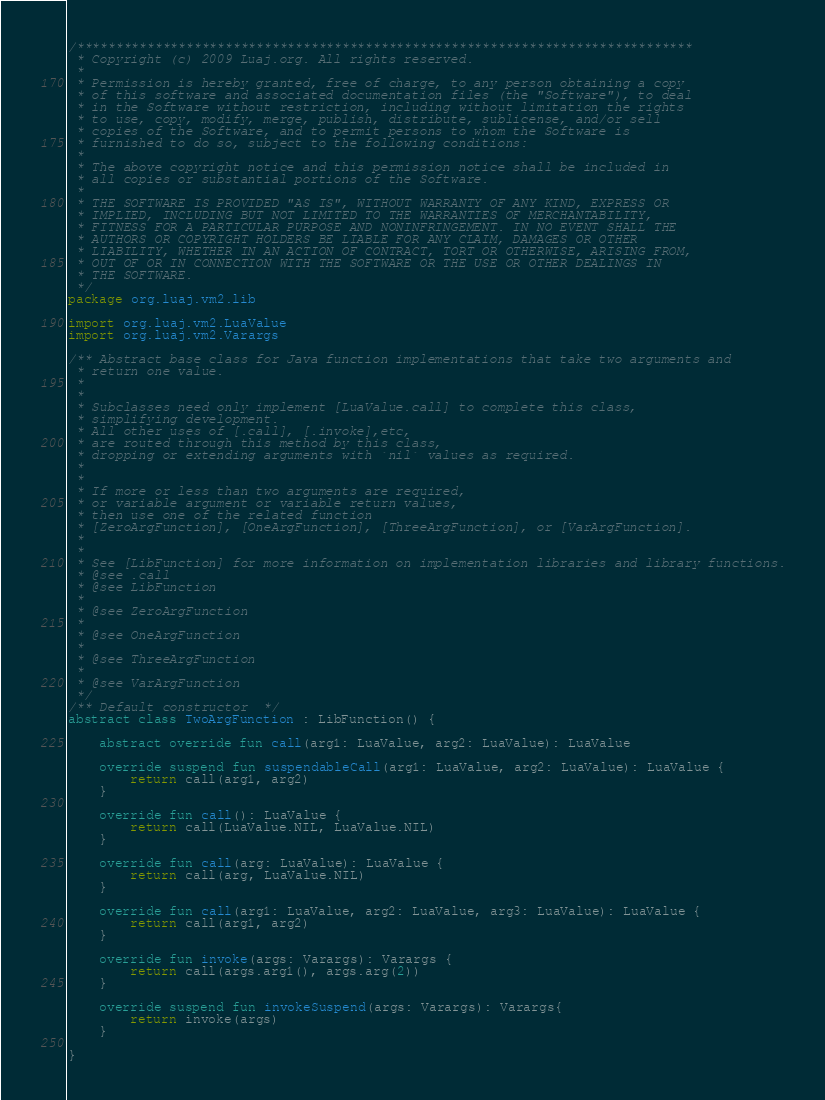Convert code to text. <code><loc_0><loc_0><loc_500><loc_500><_Kotlin_>/*******************************************************************************
 * Copyright (c) 2009 Luaj.org. All rights reserved.
 *
 * Permission is hereby granted, free of charge, to any person obtaining a copy
 * of this software and associated documentation files (the "Software"), to deal
 * in the Software without restriction, including without limitation the rights
 * to use, copy, modify, merge, publish, distribute, sublicense, and/or sell
 * copies of the Software, and to permit persons to whom the Software is
 * furnished to do so, subject to the following conditions:
 *
 * The above copyright notice and this permission notice shall be included in
 * all copies or substantial portions of the Software.
 *
 * THE SOFTWARE IS PROVIDED "AS IS", WITHOUT WARRANTY OF ANY KIND, EXPRESS OR
 * IMPLIED, INCLUDING BUT NOT LIMITED TO THE WARRANTIES OF MERCHANTABILITY,
 * FITNESS FOR A PARTICULAR PURPOSE AND NONINFRINGEMENT. IN NO EVENT SHALL THE
 * AUTHORS OR COPYRIGHT HOLDERS BE LIABLE FOR ANY CLAIM, DAMAGES OR OTHER
 * LIABILITY, WHETHER IN AN ACTION OF CONTRACT, TORT OR OTHERWISE, ARISING FROM,
 * OUT OF OR IN CONNECTION WITH THE SOFTWARE OR THE USE OR OTHER DEALINGS IN
 * THE SOFTWARE.
 */
package org.luaj.vm2.lib

import org.luaj.vm2.LuaValue
import org.luaj.vm2.Varargs

/** Abstract base class for Java function implementations that take two arguments and
 * return one value.
 *
 *
 * Subclasses need only implement [LuaValue.call] to complete this class,
 * simplifying development.
 * All other uses of [.call], [.invoke],etc,
 * are routed through this method by this class,
 * dropping or extending arguments with `nil` values as required.
 *
 *
 * If more or less than two arguments are required,
 * or variable argument or variable return values,
 * then use one of the related function
 * [ZeroArgFunction], [OneArgFunction], [ThreeArgFunction], or [VarArgFunction].
 *
 *
 * See [LibFunction] for more information on implementation libraries and library functions.
 * @see .call
 * @see LibFunction
 *
 * @see ZeroArgFunction
 *
 * @see OneArgFunction
 *
 * @see ThreeArgFunction
 *
 * @see VarArgFunction
 */
/** Default constructor  */
abstract class TwoArgFunction : LibFunction() {

    abstract override fun call(arg1: LuaValue, arg2: LuaValue): LuaValue

    override suspend fun suspendableCall(arg1: LuaValue, arg2: LuaValue): LuaValue {
        return call(arg1, arg2)
    }

    override fun call(): LuaValue {
        return call(LuaValue.NIL, LuaValue.NIL)
    }

    override fun call(arg: LuaValue): LuaValue {
        return call(arg, LuaValue.NIL)
    }

    override fun call(arg1: LuaValue, arg2: LuaValue, arg3: LuaValue): LuaValue {
        return call(arg1, arg2)
    }

    override fun invoke(args: Varargs): Varargs {
        return call(args.arg1(), args.arg(2))
    }

    override suspend fun invokeSuspend(args: Varargs): Varargs{
        return invoke(args)
    }

} 
</code> 